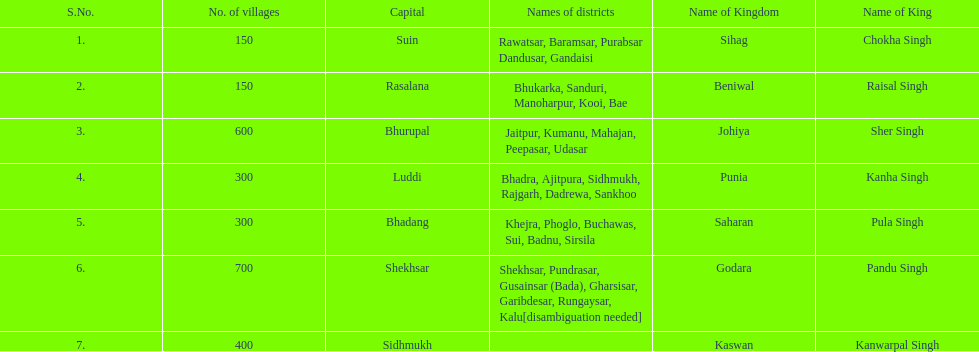What was the total number of districts within the state of godara? 7. Give me the full table as a dictionary. {'header': ['S.No.', 'No. of villages', 'Capital', 'Names of districts', 'Name of Kingdom', 'Name of King'], 'rows': [['1.', '150', 'Suin', 'Rawatsar, Baramsar, Purabsar Dandusar, Gandaisi', 'Sihag', 'Chokha Singh'], ['2.', '150', 'Rasalana', 'Bhukarka, Sanduri, Manoharpur, Kooi, Bae', 'Beniwal', 'Raisal Singh'], ['3.', '600', 'Bhurupal', 'Jaitpur, Kumanu, Mahajan, Peepasar, Udasar', 'Johiya', 'Sher Singh'], ['4.', '300', 'Luddi', 'Bhadra, Ajitpura, Sidhmukh, Rajgarh, Dadrewa, Sankhoo', 'Punia', 'Kanha Singh'], ['5.', '300', 'Bhadang', 'Khejra, Phoglo, Buchawas, Sui, Badnu, Sirsila', 'Saharan', 'Pula Singh'], ['6.', '700', 'Shekhsar', 'Shekhsar, Pundrasar, Gusainsar (Bada), Gharsisar, Garibdesar, Rungaysar, Kalu[disambiguation needed]', 'Godara', 'Pandu Singh'], ['7.', '400', 'Sidhmukh', '', 'Kaswan', 'Kanwarpal Singh']]} 